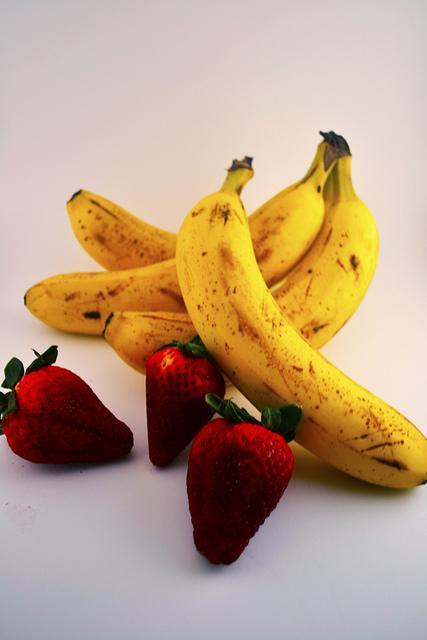How many pieces of fruit are there?
Give a very brief answer. 7. How many bananas are in the photo?
Give a very brief answer. 2. How many people are in the streets?
Give a very brief answer. 0. 